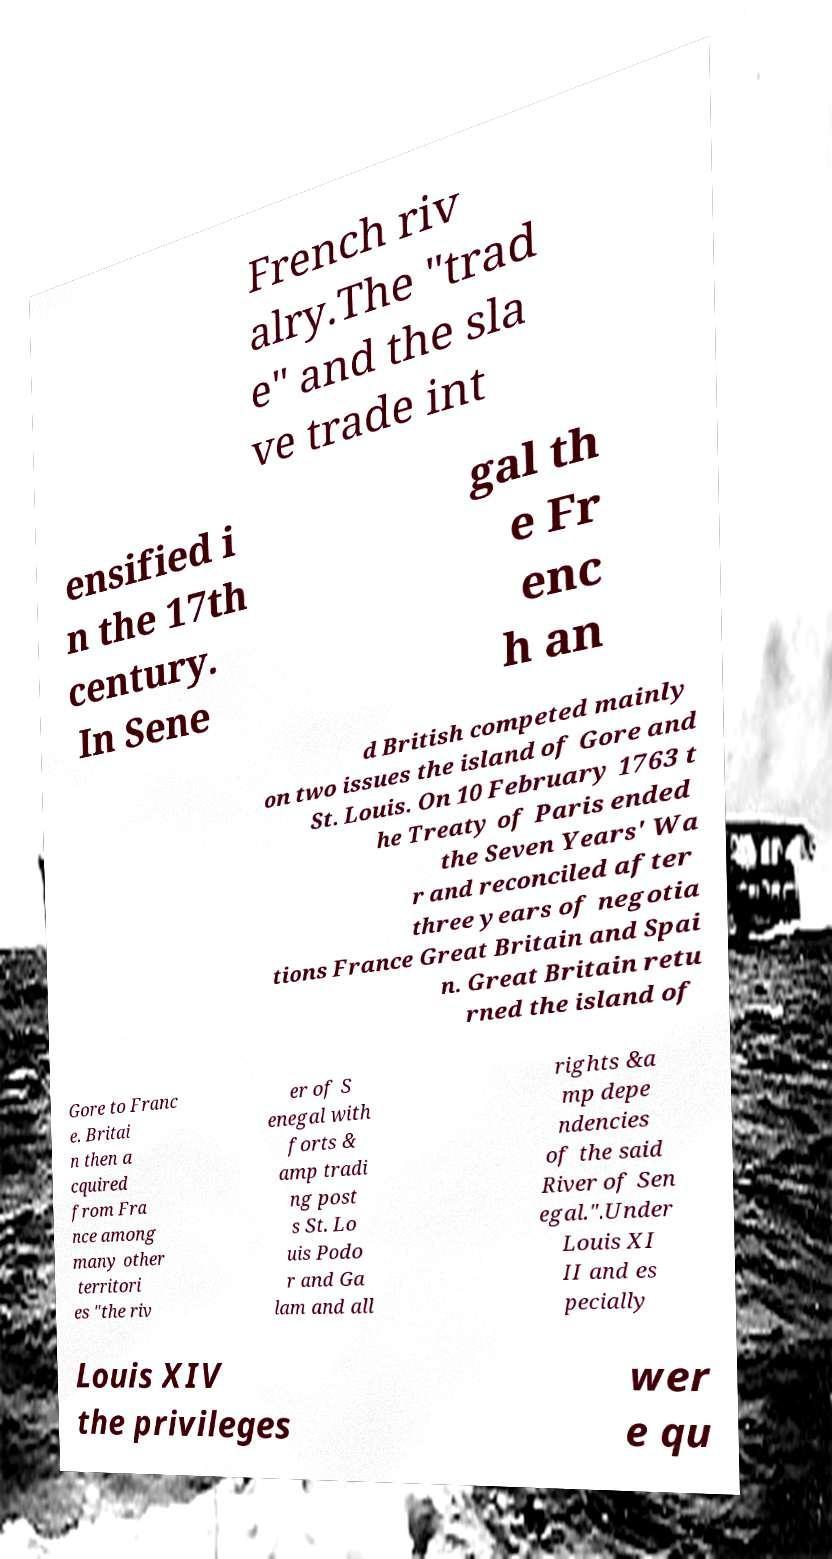Could you assist in decoding the text presented in this image and type it out clearly? French riv alry.The "trad e" and the sla ve trade int ensified i n the 17th century. In Sene gal th e Fr enc h an d British competed mainly on two issues the island of Gore and St. Louis. On 10 February 1763 t he Treaty of Paris ended the Seven Years' Wa r and reconciled after three years of negotia tions France Great Britain and Spai n. Great Britain retu rned the island of Gore to Franc e. Britai n then a cquired from Fra nce among many other territori es "the riv er of S enegal with forts & amp tradi ng post s St. Lo uis Podo r and Ga lam and all rights &a mp depe ndencies of the said River of Sen egal.".Under Louis XI II and es pecially Louis XIV the privileges wer e qu 